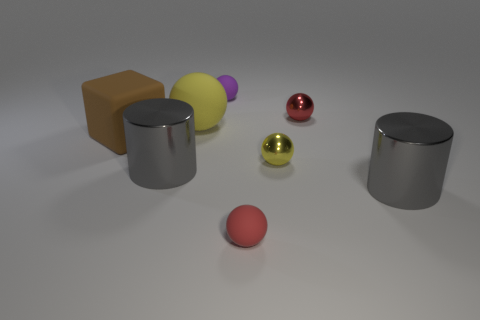Subtract all purple spheres. How many spheres are left? 4 Subtract all tiny yellow balls. How many balls are left? 4 Subtract all gray spheres. Subtract all green cylinders. How many spheres are left? 5 Add 1 yellow metal objects. How many objects exist? 9 Subtract all blocks. How many objects are left? 7 Add 1 gray shiny cylinders. How many gray shiny cylinders are left? 3 Add 4 big matte cubes. How many big matte cubes exist? 5 Subtract 2 gray cylinders. How many objects are left? 6 Subtract all tiny yellow shiny objects. Subtract all small matte balls. How many objects are left? 5 